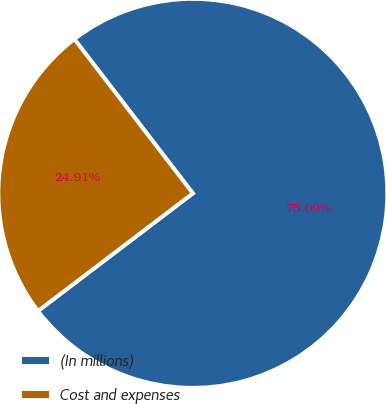Convert chart to OTSL. <chart><loc_0><loc_0><loc_500><loc_500><pie_chart><fcel>(In millions)<fcel>Cost and expenses<nl><fcel>75.09%<fcel>24.91%<nl></chart> 